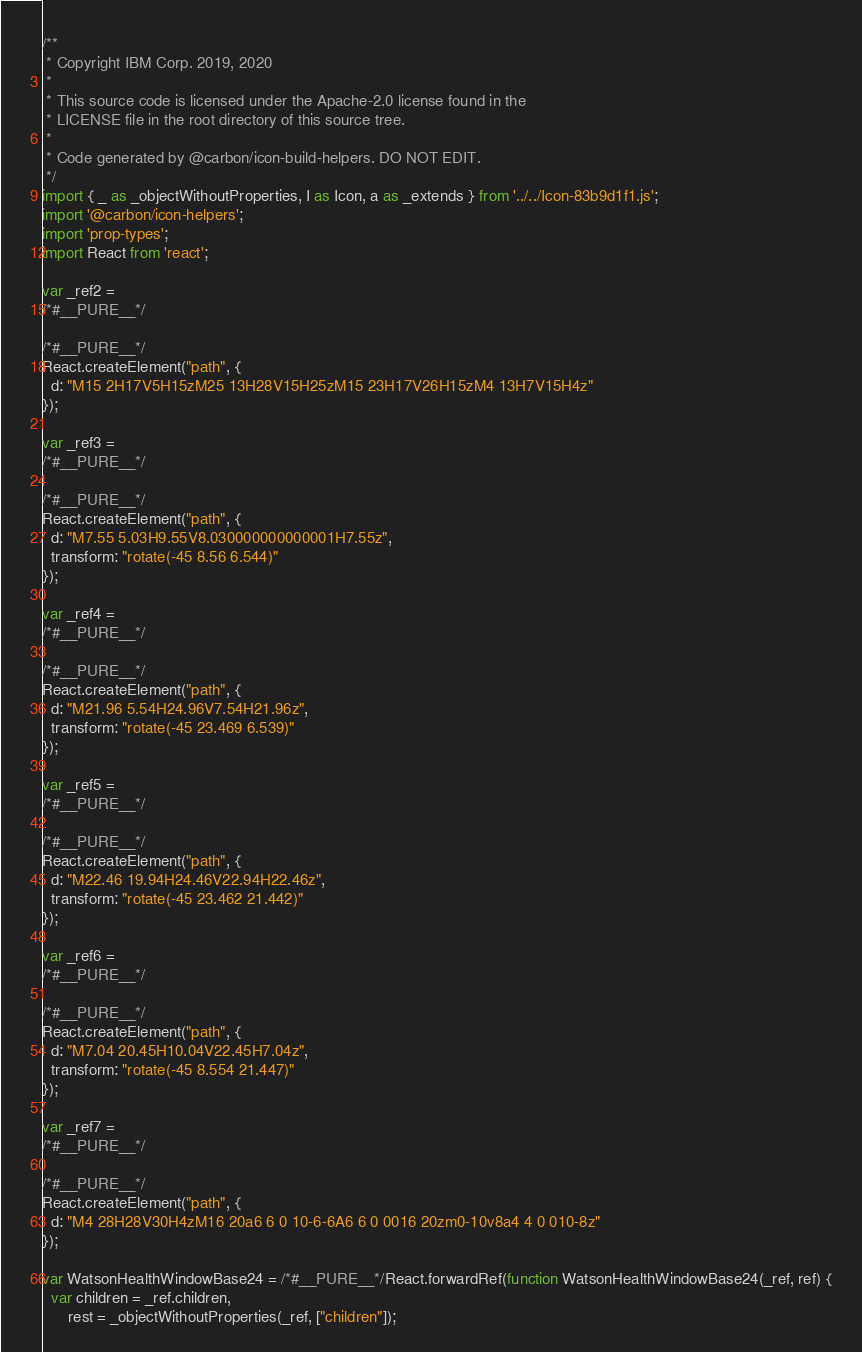<code> <loc_0><loc_0><loc_500><loc_500><_JavaScript_>/**
 * Copyright IBM Corp. 2019, 2020
 *
 * This source code is licensed under the Apache-2.0 license found in the
 * LICENSE file in the root directory of this source tree.
 *
 * Code generated by @carbon/icon-build-helpers. DO NOT EDIT.
 */
import { _ as _objectWithoutProperties, I as Icon, a as _extends } from '../../Icon-83b9d1f1.js';
import '@carbon/icon-helpers';
import 'prop-types';
import React from 'react';

var _ref2 =
/*#__PURE__*/

/*#__PURE__*/
React.createElement("path", {
  d: "M15 2H17V5H15zM25 13H28V15H25zM15 23H17V26H15zM4 13H7V15H4z"
});

var _ref3 =
/*#__PURE__*/

/*#__PURE__*/
React.createElement("path", {
  d: "M7.55 5.03H9.55V8.030000000000001H7.55z",
  transform: "rotate(-45 8.56 6.544)"
});

var _ref4 =
/*#__PURE__*/

/*#__PURE__*/
React.createElement("path", {
  d: "M21.96 5.54H24.96V7.54H21.96z",
  transform: "rotate(-45 23.469 6.539)"
});

var _ref5 =
/*#__PURE__*/

/*#__PURE__*/
React.createElement("path", {
  d: "M22.46 19.94H24.46V22.94H22.46z",
  transform: "rotate(-45 23.462 21.442)"
});

var _ref6 =
/*#__PURE__*/

/*#__PURE__*/
React.createElement("path", {
  d: "M7.04 20.45H10.04V22.45H7.04z",
  transform: "rotate(-45 8.554 21.447)"
});

var _ref7 =
/*#__PURE__*/

/*#__PURE__*/
React.createElement("path", {
  d: "M4 28H28V30H4zM16 20a6 6 0 10-6-6A6 6 0 0016 20zm0-10v8a4 4 0 010-8z"
});

var WatsonHealthWindowBase24 = /*#__PURE__*/React.forwardRef(function WatsonHealthWindowBase24(_ref, ref) {
  var children = _ref.children,
      rest = _objectWithoutProperties(_ref, ["children"]);
</code> 